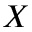<formula> <loc_0><loc_0><loc_500><loc_500>X</formula> 